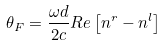Convert formula to latex. <formula><loc_0><loc_0><loc_500><loc_500>\theta _ { F } = { \frac { { \omega } d } { 2 c } } R e \left [ n ^ { r } - n ^ { l } \right ]</formula> 